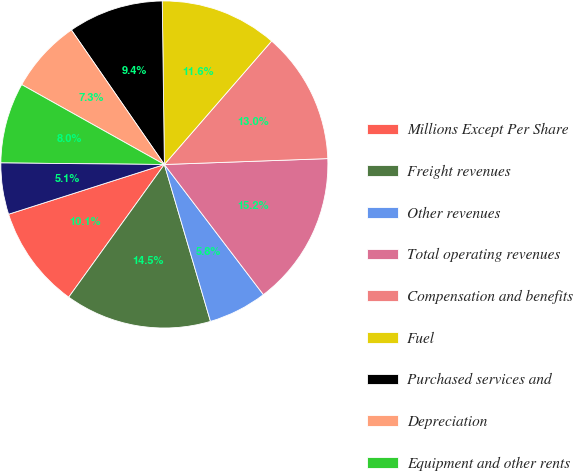Convert chart to OTSL. <chart><loc_0><loc_0><loc_500><loc_500><pie_chart><fcel>Millions Except Per Share<fcel>Freight revenues<fcel>Other revenues<fcel>Total operating revenues<fcel>Compensation and benefits<fcel>Fuel<fcel>Purchased services and<fcel>Depreciation<fcel>Equipment and other rents<fcel>Other<nl><fcel>10.14%<fcel>14.49%<fcel>5.8%<fcel>15.22%<fcel>13.04%<fcel>11.59%<fcel>9.42%<fcel>7.25%<fcel>7.97%<fcel>5.07%<nl></chart> 